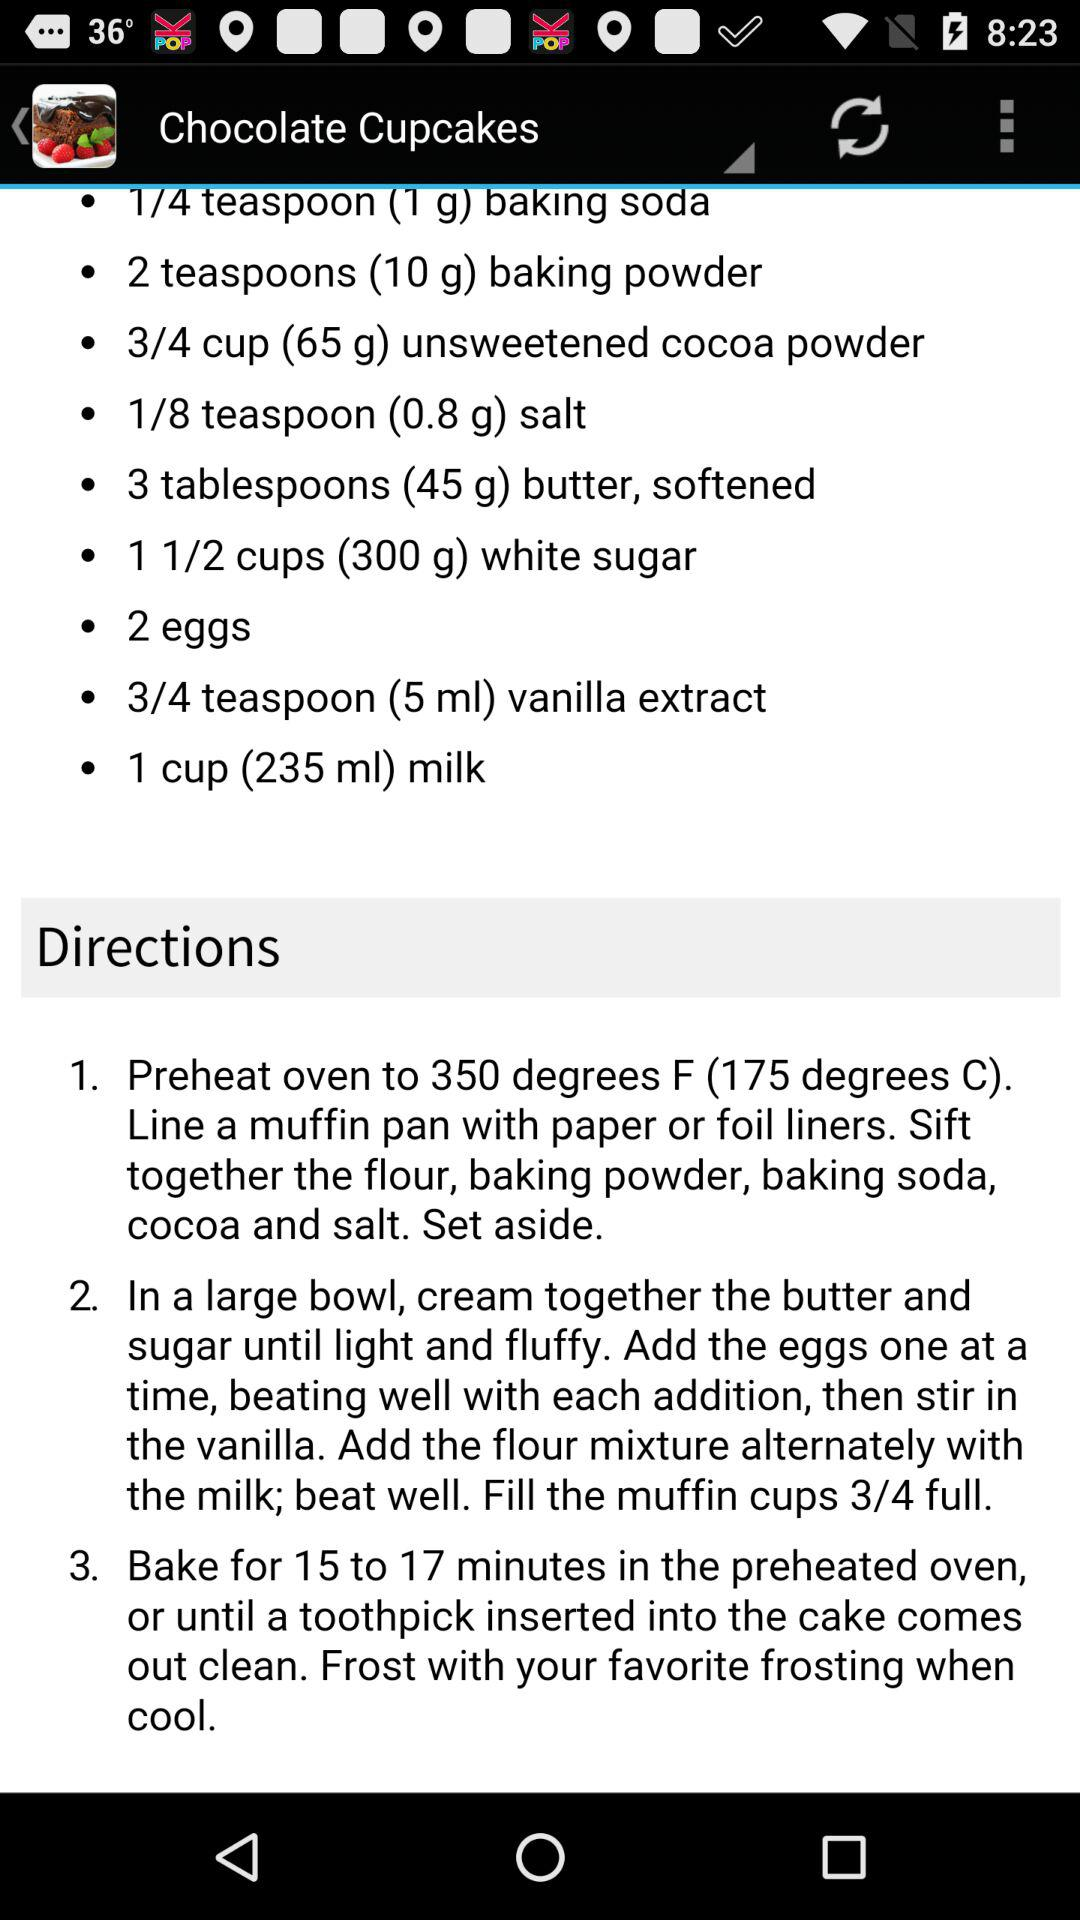What is the given amount of milk for a chocolate cupcake? The given amount of milk for a chocolate cupcake is 1 cup (235 ml). 